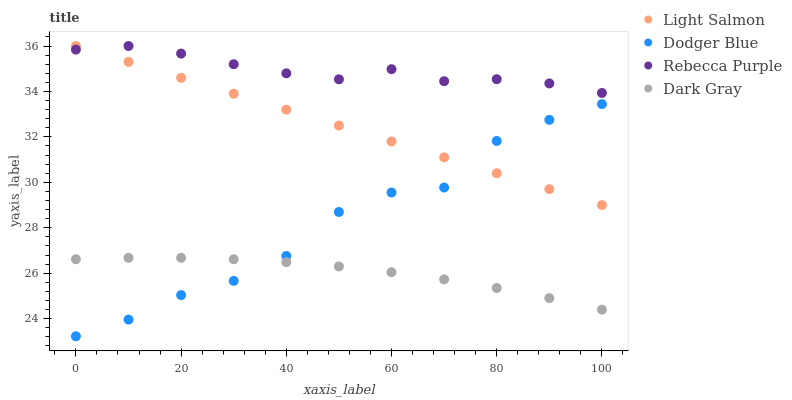Does Dark Gray have the minimum area under the curve?
Answer yes or no. Yes. Does Rebecca Purple have the maximum area under the curve?
Answer yes or no. Yes. Does Light Salmon have the minimum area under the curve?
Answer yes or no. No. Does Light Salmon have the maximum area under the curve?
Answer yes or no. No. Is Light Salmon the smoothest?
Answer yes or no. Yes. Is Dodger Blue the roughest?
Answer yes or no. Yes. Is Dodger Blue the smoothest?
Answer yes or no. No. Is Light Salmon the roughest?
Answer yes or no. No. Does Dodger Blue have the lowest value?
Answer yes or no. Yes. Does Light Salmon have the lowest value?
Answer yes or no. No. Does Rebecca Purple have the highest value?
Answer yes or no. Yes. Does Dodger Blue have the highest value?
Answer yes or no. No. Is Dark Gray less than Light Salmon?
Answer yes or no. Yes. Is Rebecca Purple greater than Dark Gray?
Answer yes or no. Yes. Does Dodger Blue intersect Dark Gray?
Answer yes or no. Yes. Is Dodger Blue less than Dark Gray?
Answer yes or no. No. Is Dodger Blue greater than Dark Gray?
Answer yes or no. No. Does Dark Gray intersect Light Salmon?
Answer yes or no. No. 